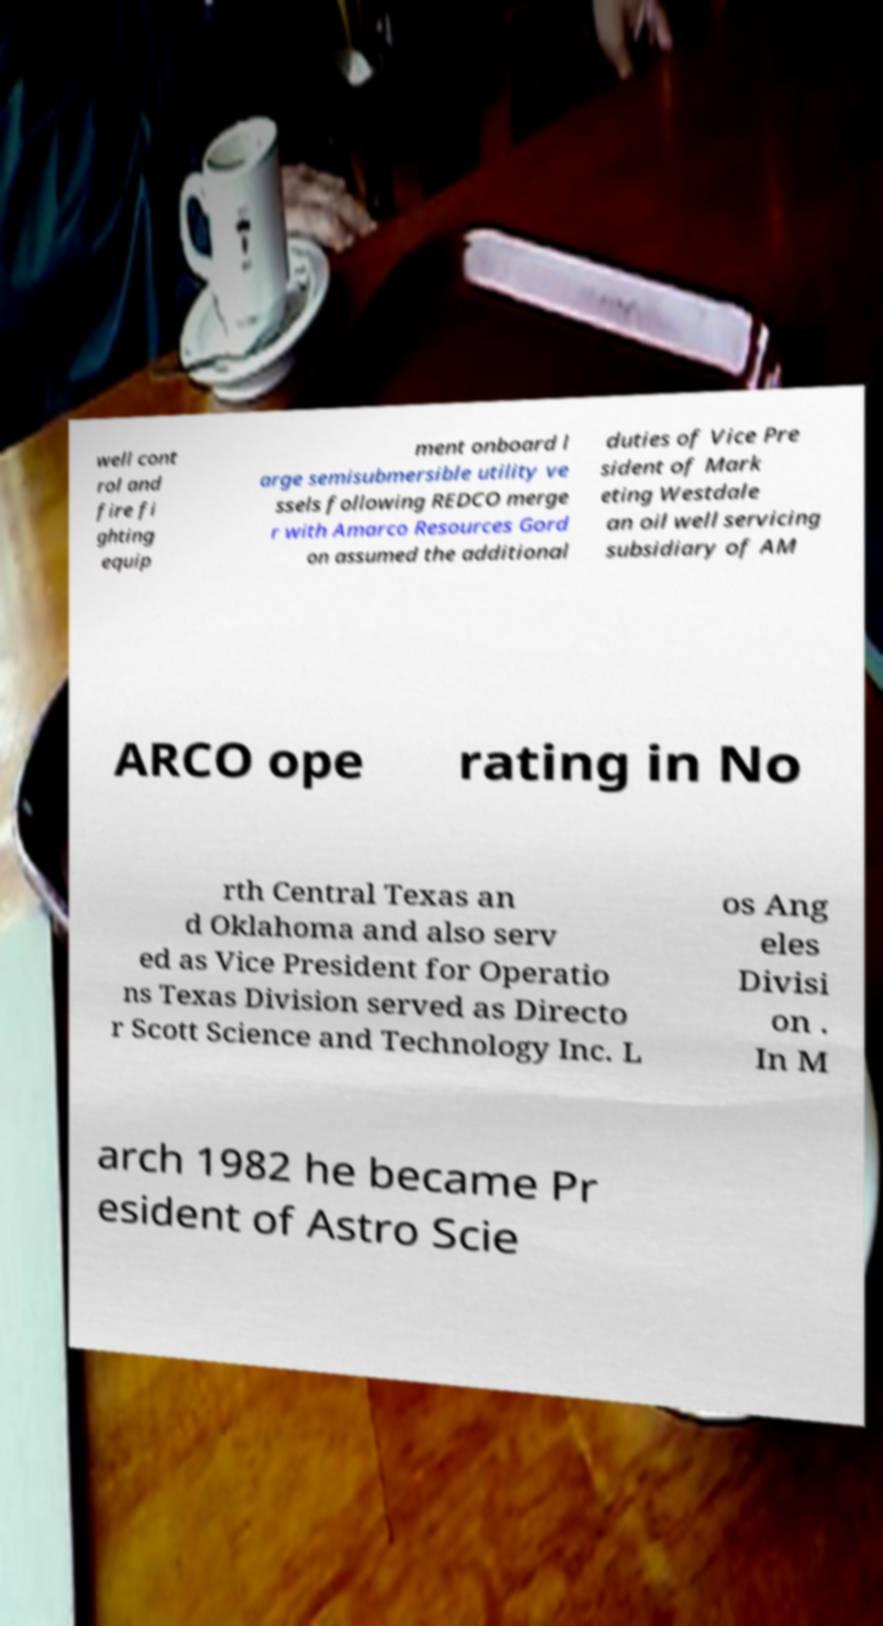Please identify and transcribe the text found in this image. well cont rol and fire fi ghting equip ment onboard l arge semisubmersible utility ve ssels following REDCO merge r with Amarco Resources Gord on assumed the additional duties of Vice Pre sident of Mark eting Westdale an oil well servicing subsidiary of AM ARCO ope rating in No rth Central Texas an d Oklahoma and also serv ed as Vice President for Operatio ns Texas Division served as Directo r Scott Science and Technology Inc. L os Ang eles Divisi on . In M arch 1982 he became Pr esident of Astro Scie 